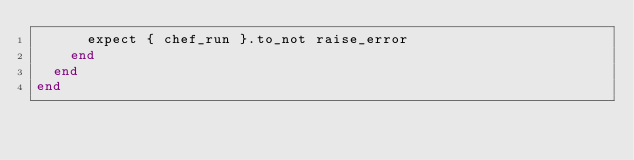<code> <loc_0><loc_0><loc_500><loc_500><_Ruby_>      expect { chef_run }.to_not raise_error
    end
  end
end
</code> 